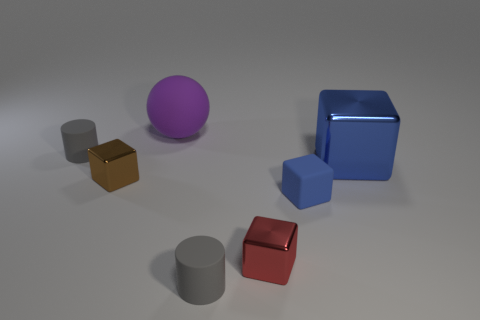What is the color of the large thing that is the same material as the red block?
Offer a very short reply. Blue. There is a tiny metal thing in front of the blue matte block; what number of tiny blue blocks are in front of it?
Offer a very short reply. 0. What material is the object that is on the right side of the red metal cube and in front of the blue metallic object?
Give a very brief answer. Rubber. There is a big thing in front of the purple object; does it have the same shape as the blue matte thing?
Provide a short and direct response. Yes. Are there fewer matte things than things?
Your answer should be compact. Yes. How many tiny matte blocks are the same color as the large cube?
Provide a succinct answer. 1. There is another object that is the same color as the large metallic object; what material is it?
Ensure brevity in your answer.  Rubber. Do the big block and the tiny matte object that is on the right side of the red block have the same color?
Provide a short and direct response. Yes. Are there more tiny blocks than green objects?
Offer a terse response. Yes. There is a blue shiny object that is the same shape as the tiny red object; what size is it?
Your answer should be very brief. Large. 